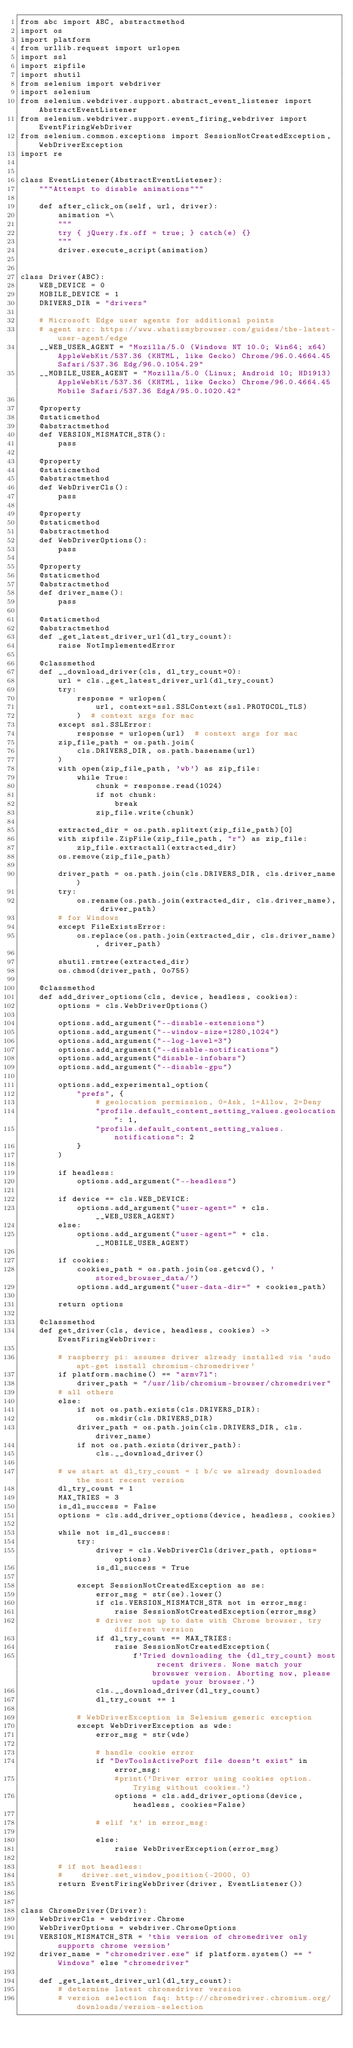Convert code to text. <code><loc_0><loc_0><loc_500><loc_500><_Python_>from abc import ABC, abstractmethod
import os
import platform
from urllib.request import urlopen
import ssl
import zipfile
import shutil
from selenium import webdriver
import selenium
from selenium.webdriver.support.abstract_event_listener import AbstractEventListener
from selenium.webdriver.support.event_firing_webdriver import EventFiringWebDriver
from selenium.common.exceptions import SessionNotCreatedException, WebDriverException
import re


class EventListener(AbstractEventListener):
    """Attempt to disable animations"""

    def after_click_on(self, url, driver):
        animation =\
        """
        try { jQuery.fx.off = true; } catch(e) {}
        """
        driver.execute_script(animation)


class Driver(ABC):
    WEB_DEVICE = 0
    MOBILE_DEVICE = 1
    DRIVERS_DIR = "drivers"

    # Microsoft Edge user agents for additional points
    # agent src: https://www.whatismybrowser.com/guides/the-latest-user-agent/edge
    __WEB_USER_AGENT = "Mozilla/5.0 (Windows NT 10.0; Win64; x64) AppleWebKit/537.36 (KHTML, like Gecko) Chrome/96.0.4664.45 Safari/537.36 Edg/96.0.1054.29"
    __MOBILE_USER_AGENT = "Mozilla/5.0 (Linux; Android 10; HD1913) AppleWebKit/537.36 (KHTML, like Gecko) Chrome/96.0.4664.45 Mobile Safari/537.36 EdgA/95.0.1020.42"

    @property
    @staticmethod
    @abstractmethod
    def VERSION_MISMATCH_STR():
        pass

    @property
    @staticmethod
    @abstractmethod
    def WebDriverCls():
        pass

    @property
    @staticmethod
    @abstractmethod
    def WebDriverOptions():
        pass

    @property
    @staticmethod
    @abstractmethod
    def driver_name():
        pass

    @staticmethod
    @abstractmethod
    def _get_latest_driver_url(dl_try_count):
        raise NotImplementedError

    @classmethod
    def __download_driver(cls, dl_try_count=0):
        url = cls._get_latest_driver_url(dl_try_count)
        try:
            response = urlopen(
                url, context=ssl.SSLContext(ssl.PROTOCOL_TLS)
            )  # context args for mac
        except ssl.SSLError:
            response = urlopen(url)  # context args for mac
        zip_file_path = os.path.join(
            cls.DRIVERS_DIR, os.path.basename(url)
        )
        with open(zip_file_path, 'wb') as zip_file:
            while True:
                chunk = response.read(1024)
                if not chunk:
                    break
                zip_file.write(chunk)

        extracted_dir = os.path.splitext(zip_file_path)[0]
        with zipfile.ZipFile(zip_file_path, "r") as zip_file:
            zip_file.extractall(extracted_dir)
        os.remove(zip_file_path)

        driver_path = os.path.join(cls.DRIVERS_DIR, cls.driver_name)
        try:
            os.rename(os.path.join(extracted_dir, cls.driver_name), driver_path)
        # for Windows
        except FileExistsError:
            os.replace(os.path.join(extracted_dir, cls.driver_name), driver_path)

        shutil.rmtree(extracted_dir)
        os.chmod(driver_path, 0o755)

    @classmethod
    def add_driver_options(cls, device, headless, cookies):
        options = cls.WebDriverOptions()

        options.add_argument("--disable-extensions")
        options.add_argument("--window-size=1280,1024")
        options.add_argument("--log-level=3")
        options.add_argument("--disable-notifications")
        options.add_argument("disable-infobars")
        options.add_argument("--disable-gpu")

        options.add_experimental_option(
            "prefs", {
                # geolocation permission, 0=Ask, 1=Allow, 2=Deny
                "profile.default_content_setting_values.geolocation": 1,
                "profile.default_content_setting_values.notifications": 2
            }
        )

        if headless:
            options.add_argument("--headless")

        if device == cls.WEB_DEVICE:
            options.add_argument("user-agent=" + cls.__WEB_USER_AGENT)
        else:
            options.add_argument("user-agent=" + cls.__MOBILE_USER_AGENT)

        if cookies:
            cookies_path = os.path.join(os.getcwd(), 'stored_browser_data/')
            options.add_argument("user-data-dir=" + cookies_path)

        return options

    @classmethod
    def get_driver(cls, device, headless, cookies) -> EventFiringWebDriver:

        # raspberry pi: assumes driver already installed via `sudo apt-get install chromium-chromedriver`
        if platform.machine() == "armv7l":
            driver_path = "/usr/lib/chromium-browser/chromedriver"
        # all others
        else:
            if not os.path.exists(cls.DRIVERS_DIR):
                os.mkdir(cls.DRIVERS_DIR)
            driver_path = os.path.join(cls.DRIVERS_DIR, cls.driver_name)
            if not os.path.exists(driver_path):
                cls.__download_driver()

        # we start at dl_try_count = 1 b/c we already downloaded the most recent version
        dl_try_count = 1
        MAX_TRIES = 3
        is_dl_success = False
        options = cls.add_driver_options(device, headless, cookies)

        while not is_dl_success:
            try:
                driver = cls.WebDriverCls(driver_path, options=options)
                is_dl_success = True

            except SessionNotCreatedException as se:
                error_msg = str(se).lower()
                if cls.VERSION_MISMATCH_STR not in error_msg:
                    raise SessionNotCreatedException(error_msg)
                # driver not up to date with Chrome browser, try different version
                if dl_try_count == MAX_TRIES:
                    raise SessionNotCreatedException(
                        f'Tried downloading the {dl_try_count} most recent drivers. None match your browswer version. Aborting now, please update your browser.')
                cls.__download_driver(dl_try_count)
                dl_try_count += 1

            # WebDriverException is Selenium generic exception
            except WebDriverException as wde:
                error_msg = str(wde)

                # handle cookie error
                if "DevToolsActivePort file doesn't exist" in error_msg:
                    #print('Driver error using cookies option. Trying without cookies.')
                    options = cls.add_driver_options(device, headless, cookies=False)

                # elif 'x' in error_msg:

                else:
                    raise WebDriverException(error_msg)

        # if not headless:
        #    driver.set_window_position(-2000, 0)
        return EventFiringWebDriver(driver, EventListener())


class ChromeDriver(Driver):
    WebDriverCls = webdriver.Chrome
    WebDriverOptions = webdriver.ChromeOptions
    VERSION_MISMATCH_STR = 'this version of chromedriver only supports chrome version'
    driver_name = "chromedriver.exe" if platform.system() == "Windows" else "chromedriver"

    def _get_latest_driver_url(dl_try_count):
        # determine latest chromedriver version
        # version selection faq: http://chromedriver.chromium.org/downloads/version-selection</code> 